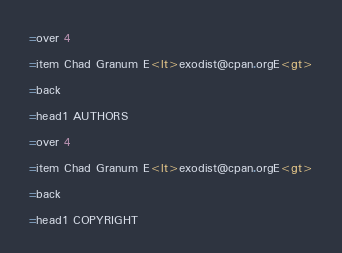<code> <loc_0><loc_0><loc_500><loc_500><_Perl_>=over 4

=item Chad Granum E<lt>exodist@cpan.orgE<gt>

=back

=head1 AUTHORS

=over 4

=item Chad Granum E<lt>exodist@cpan.orgE<gt>

=back

=head1 COPYRIGHT
</code> 